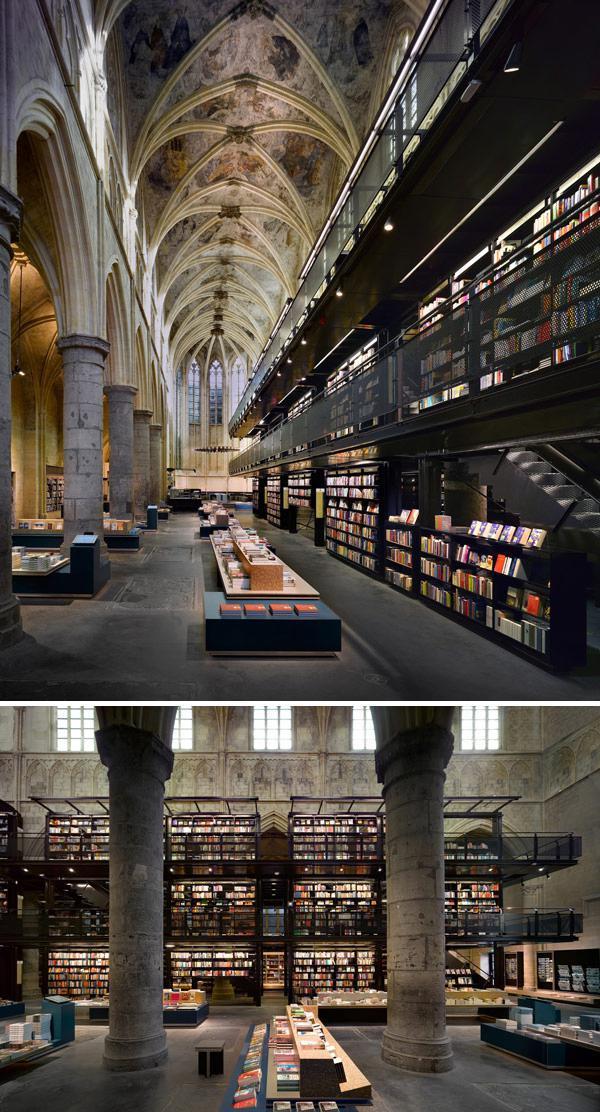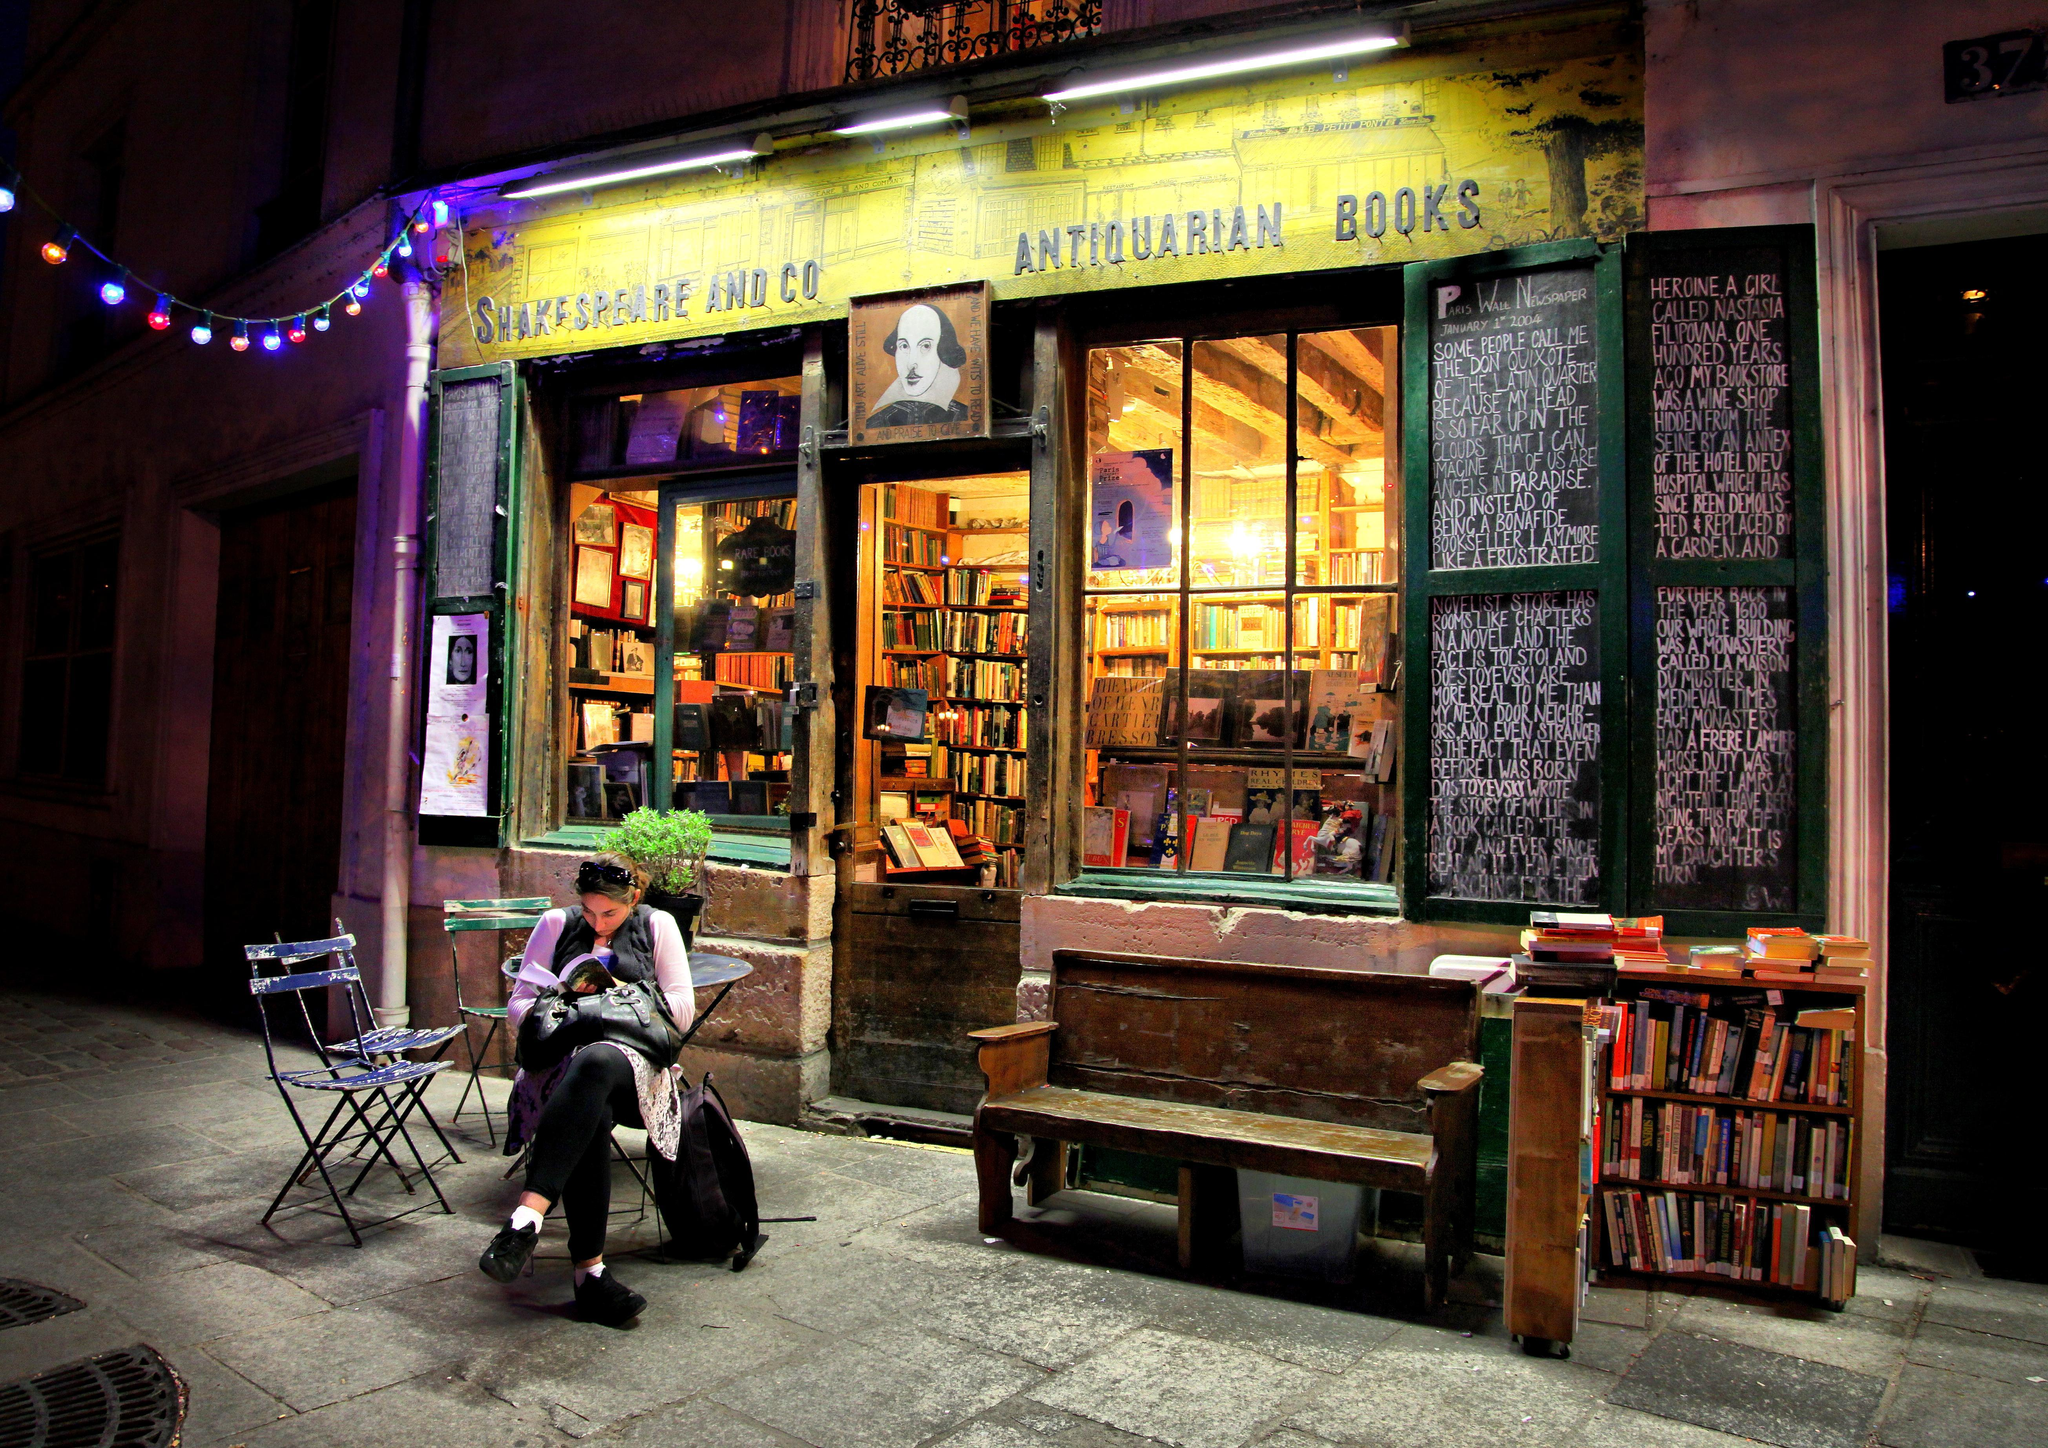The first image is the image on the left, the second image is the image on the right. Analyze the images presented: Is the assertion "A person is sitting down." valid? Answer yes or no. Yes. 